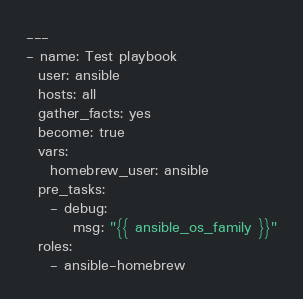Convert code to text. <code><loc_0><loc_0><loc_500><loc_500><_YAML_>---
- name: Test playbook
  user: ansible
  hosts: all
  gather_facts: yes
  become: true
  vars:
    homebrew_user: ansible
  pre_tasks:
    - debug:
        msg: "{{ ansible_os_family }}"
  roles:
    - ansible-homebrew</code> 